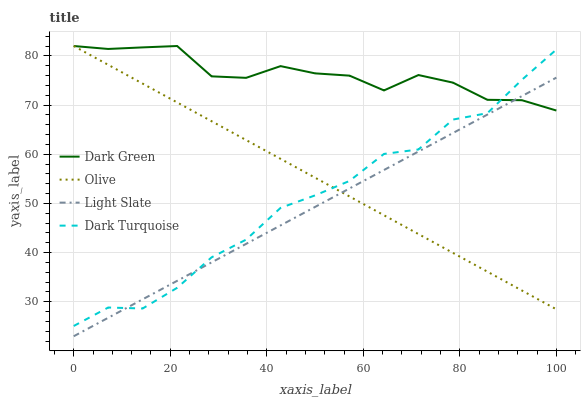Does Dark Turquoise have the minimum area under the curve?
Answer yes or no. No. Does Dark Turquoise have the maximum area under the curve?
Answer yes or no. No. Is Dark Turquoise the smoothest?
Answer yes or no. No. Is Light Slate the roughest?
Answer yes or no. No. Does Dark Turquoise have the lowest value?
Answer yes or no. No. Does Dark Turquoise have the highest value?
Answer yes or no. No. 